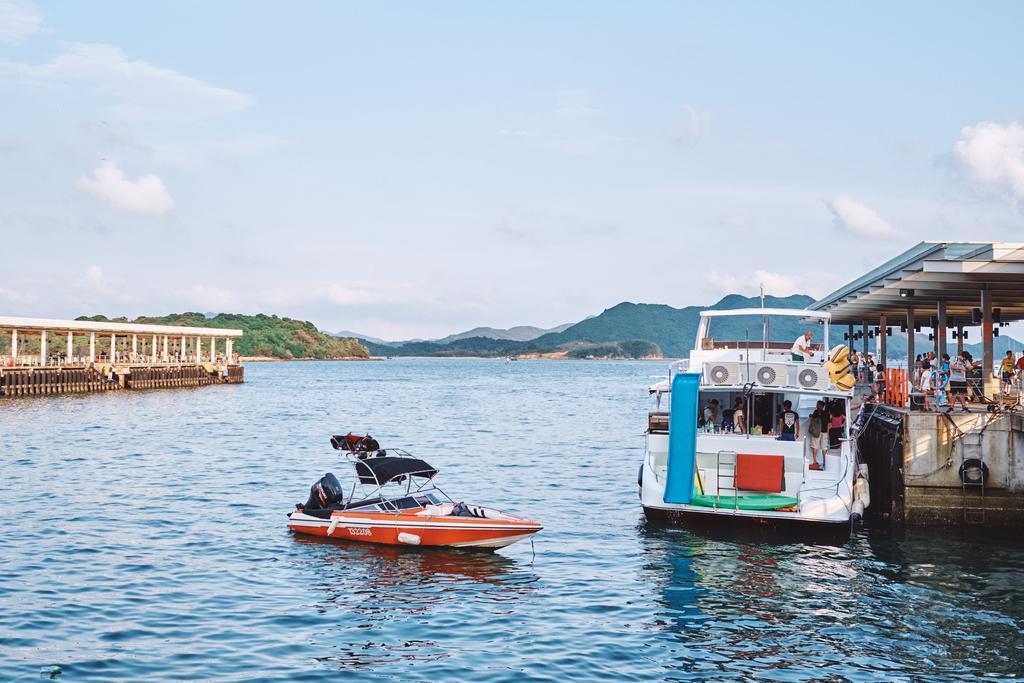In one or two sentences, can you explain what this image depicts? In this picture I can see the water in front, on which I can see 2 boats and on the right side of this picture I can see few people on a thing and I see few rods. I can also see few people on the boat. In the background I can see the mountains and the sky. On the left side of this image I can see few pillars. 